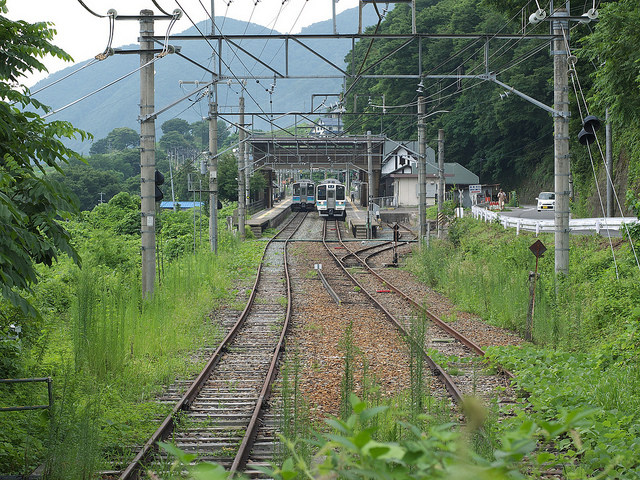There are two trains going down the rail of likely what country?
A. canada
B. united states
C. japan
D. korea
Answer with the option's letter from the given choices directly. C How many trains could be traveling underneath of these wires overhanging the train track?
A. three
B. two
C. five
D. four B 